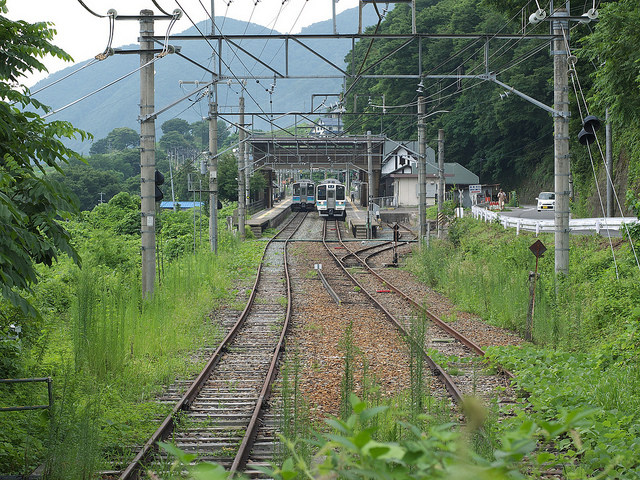There are two trains going down the rail of likely what country?
A. canada
B. united states
C. japan
D. korea
Answer with the option's letter from the given choices directly. C How many trains could be traveling underneath of these wires overhanging the train track?
A. three
B. two
C. five
D. four B 